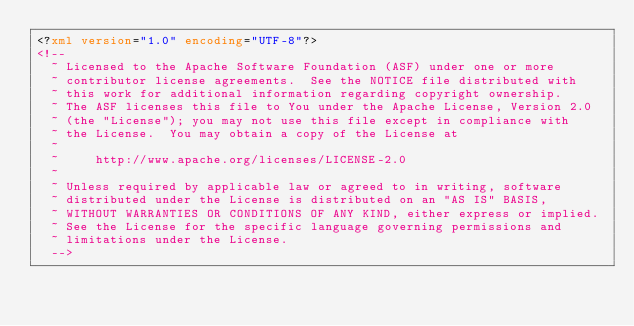<code> <loc_0><loc_0><loc_500><loc_500><_XML_><?xml version="1.0" encoding="UTF-8"?>
<!--
  ~ Licensed to the Apache Software Foundation (ASF) under one or more
  ~ contributor license agreements.  See the NOTICE file distributed with
  ~ this work for additional information regarding copyright ownership.
  ~ The ASF licenses this file to You under the Apache License, Version 2.0
  ~ (the "License"); you may not use this file except in compliance with
  ~ the License.  You may obtain a copy of the License at
  ~
  ~     http://www.apache.org/licenses/LICENSE-2.0
  ~
  ~ Unless required by applicable law or agreed to in writing, software
  ~ distributed under the License is distributed on an "AS IS" BASIS,
  ~ WITHOUT WARRANTIES OR CONDITIONS OF ANY KIND, either express or implied.
  ~ See the License for the specific language governing permissions and
  ~ limitations under the License.
  -->
</code> 